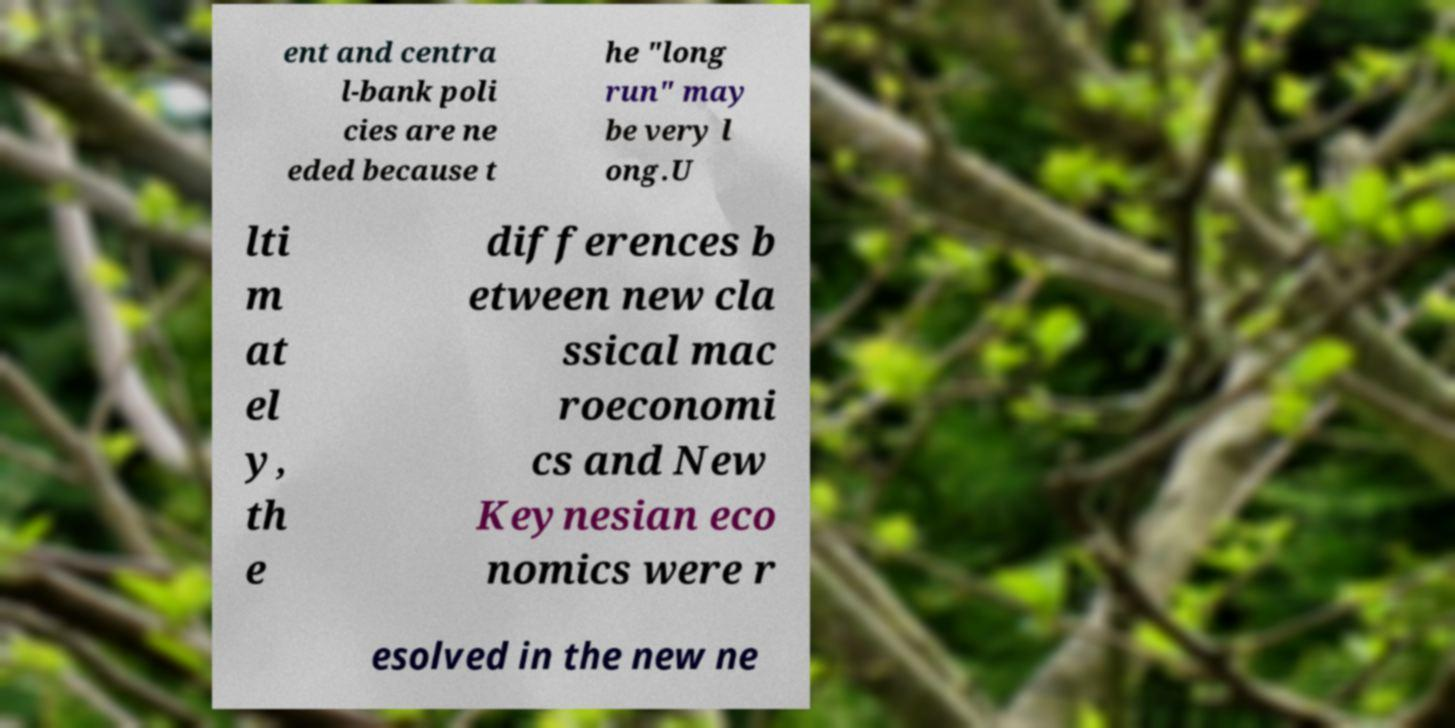Please identify and transcribe the text found in this image. ent and centra l-bank poli cies are ne eded because t he "long run" may be very l ong.U lti m at el y, th e differences b etween new cla ssical mac roeconomi cs and New Keynesian eco nomics were r esolved in the new ne 